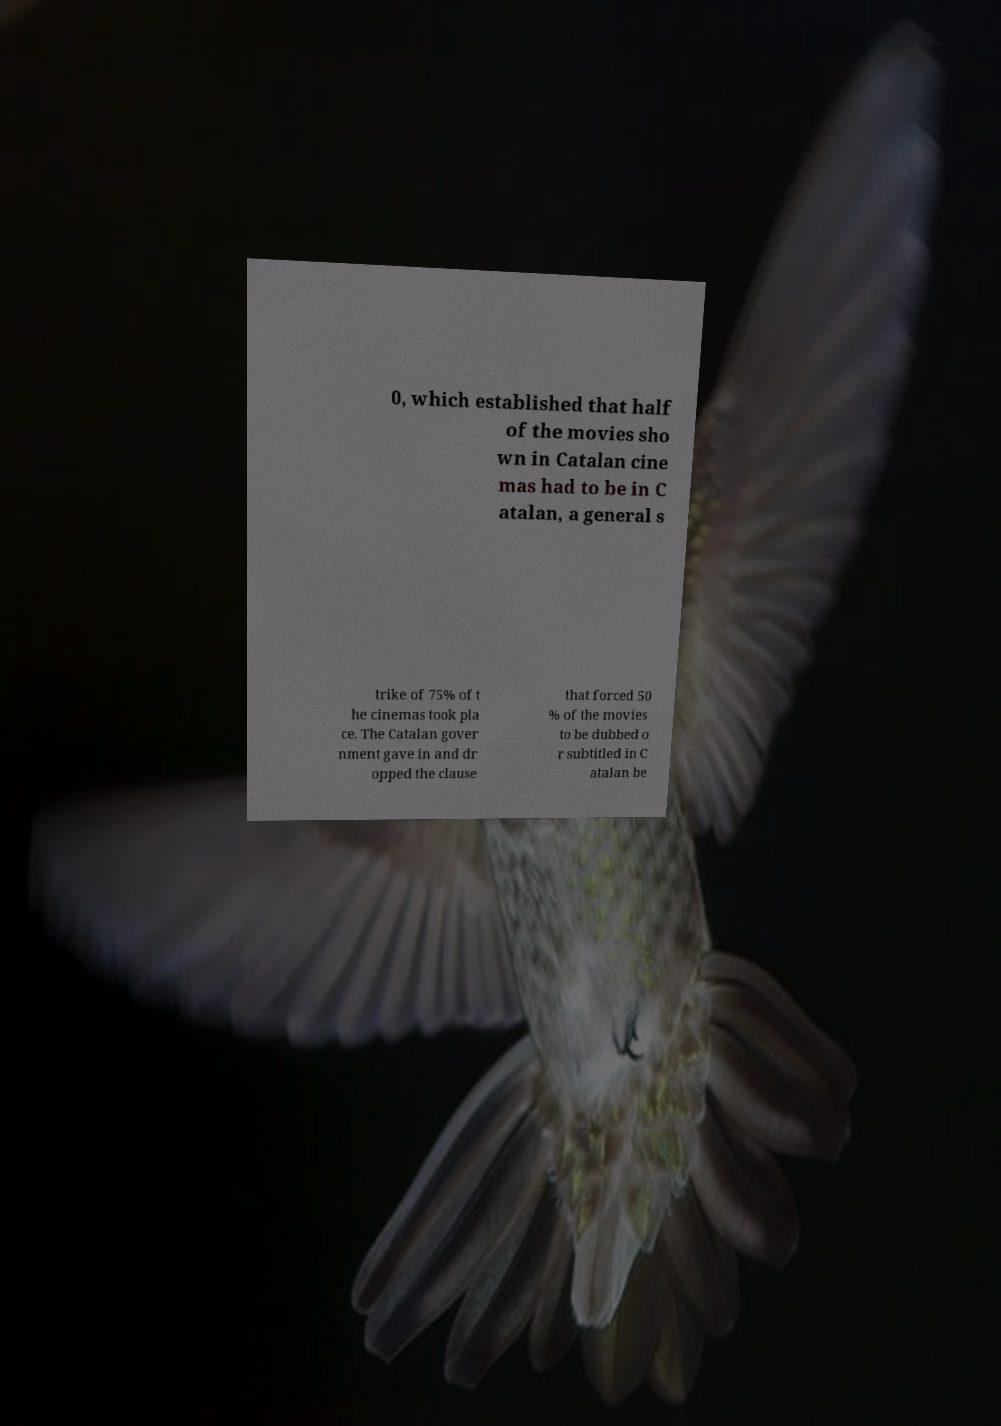Can you read and provide the text displayed in the image?This photo seems to have some interesting text. Can you extract and type it out for me? 0, which established that half of the movies sho wn in Catalan cine mas had to be in C atalan, a general s trike of 75% of t he cinemas took pla ce. The Catalan gover nment gave in and dr opped the clause that forced 50 % of the movies to be dubbed o r subtitled in C atalan be 